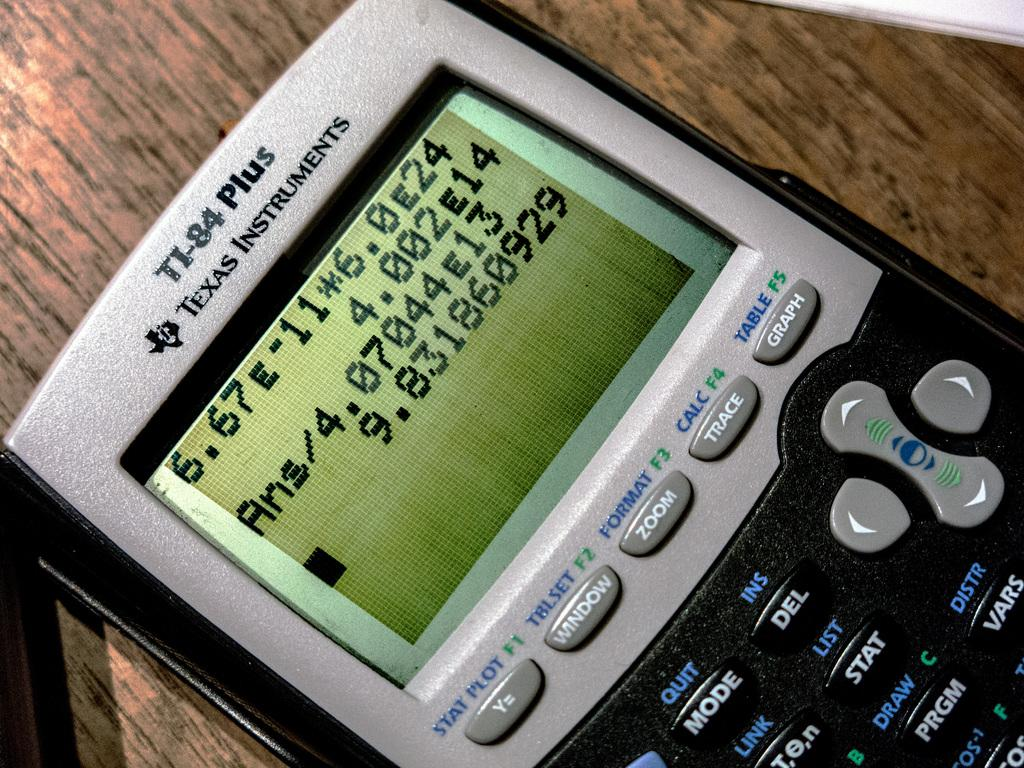<image>
Create a compact narrative representing the image presented. a TI-84 Plus Texas Instruments calculator with a large sum on the screen 